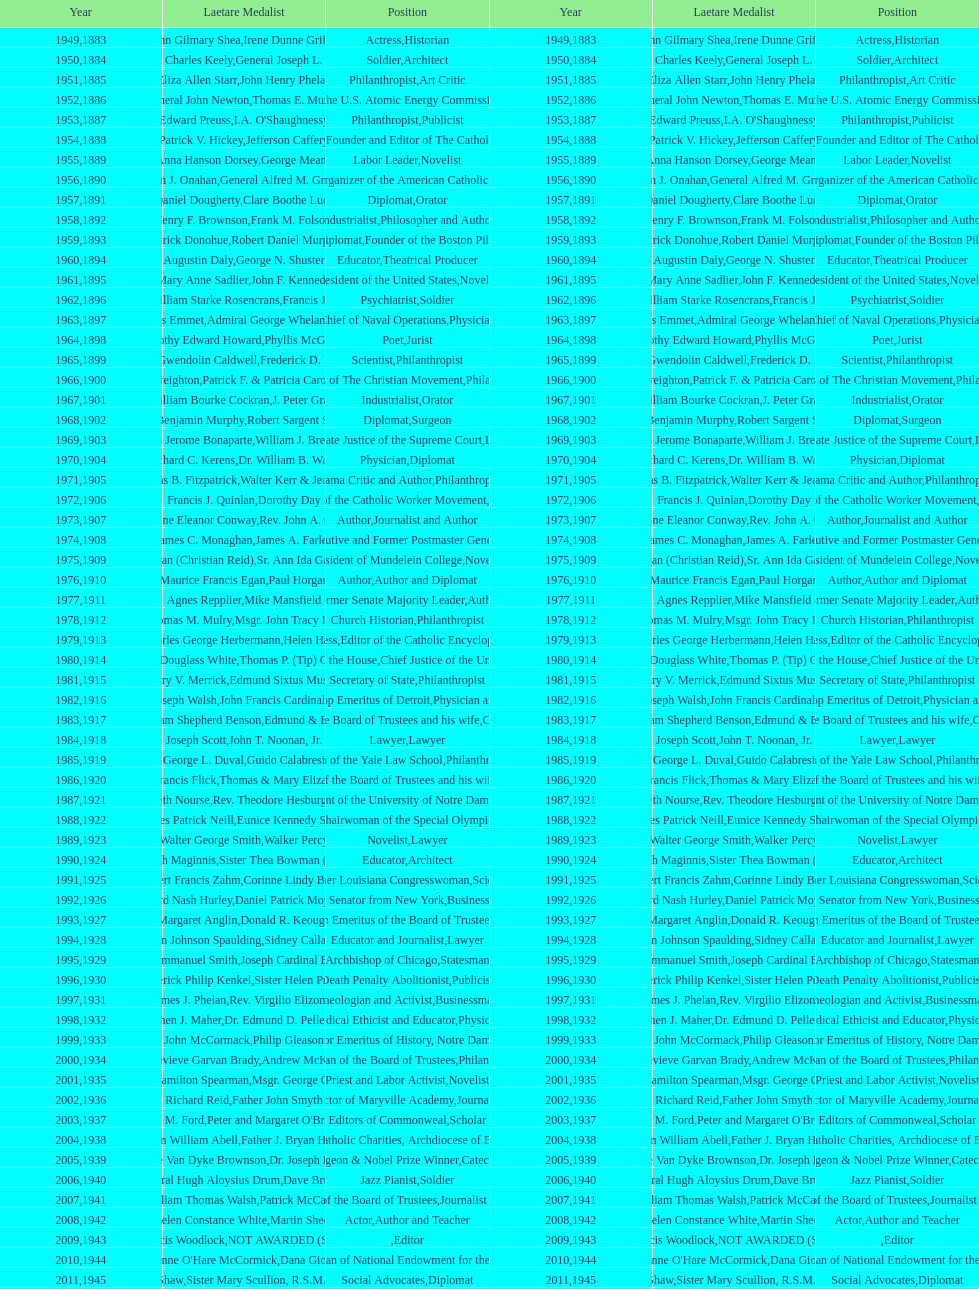How many are or were journalists? 5. 